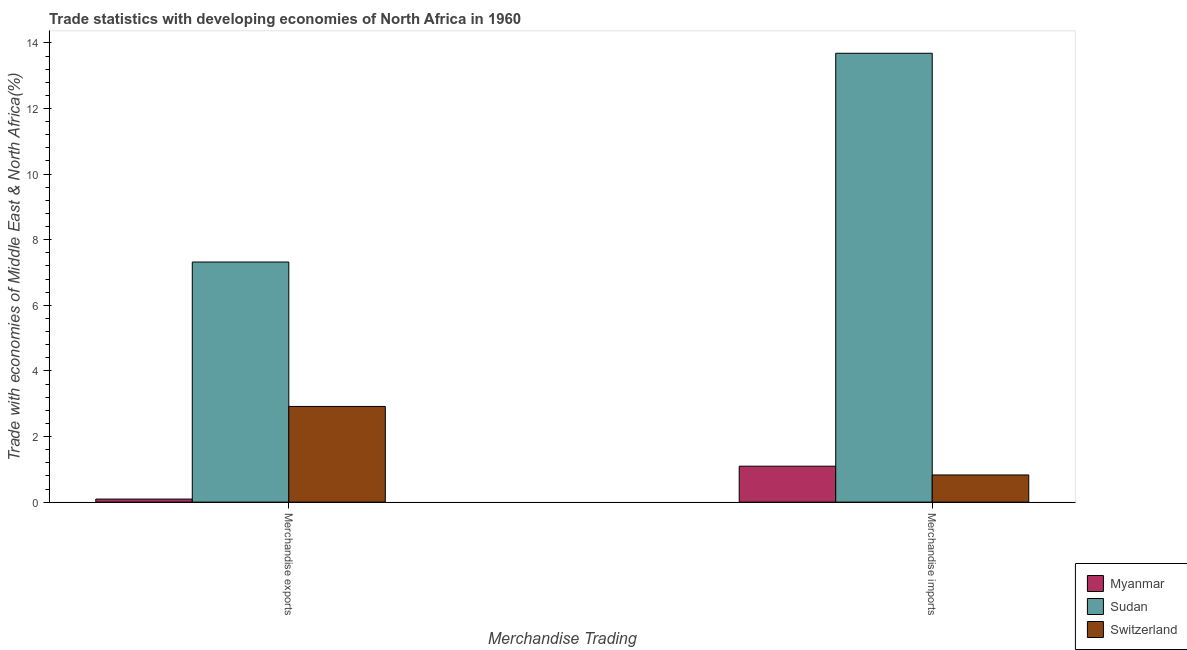Are the number of bars per tick equal to the number of legend labels?
Provide a succinct answer. Yes. Are the number of bars on each tick of the X-axis equal?
Ensure brevity in your answer.  Yes. How many bars are there on the 2nd tick from the left?
Your response must be concise. 3. How many bars are there on the 1st tick from the right?
Your response must be concise. 3. What is the merchandise imports in Myanmar?
Ensure brevity in your answer.  1.1. Across all countries, what is the maximum merchandise imports?
Make the answer very short. 13.68. Across all countries, what is the minimum merchandise exports?
Your response must be concise. 0.09. In which country was the merchandise imports maximum?
Make the answer very short. Sudan. In which country was the merchandise imports minimum?
Your answer should be compact. Switzerland. What is the total merchandise exports in the graph?
Your answer should be very brief. 10.33. What is the difference between the merchandise imports in Myanmar and that in Switzerland?
Your answer should be compact. 0.27. What is the difference between the merchandise exports in Switzerland and the merchandise imports in Myanmar?
Offer a terse response. 1.82. What is the average merchandise exports per country?
Offer a terse response. 3.44. What is the difference between the merchandise exports and merchandise imports in Sudan?
Keep it short and to the point. -6.36. What is the ratio of the merchandise imports in Switzerland to that in Myanmar?
Your response must be concise. 0.76. In how many countries, is the merchandise imports greater than the average merchandise imports taken over all countries?
Keep it short and to the point. 1. What does the 3rd bar from the left in Merchandise imports represents?
Ensure brevity in your answer.  Switzerland. What does the 2nd bar from the right in Merchandise imports represents?
Provide a succinct answer. Sudan. Does the graph contain grids?
Your answer should be very brief. No. What is the title of the graph?
Your answer should be compact. Trade statistics with developing economies of North Africa in 1960. What is the label or title of the X-axis?
Your answer should be very brief. Merchandise Trading. What is the label or title of the Y-axis?
Make the answer very short. Trade with economies of Middle East & North Africa(%). What is the Trade with economies of Middle East & North Africa(%) in Myanmar in Merchandise exports?
Your answer should be compact. 0.09. What is the Trade with economies of Middle East & North Africa(%) in Sudan in Merchandise exports?
Your response must be concise. 7.32. What is the Trade with economies of Middle East & North Africa(%) in Switzerland in Merchandise exports?
Make the answer very short. 2.92. What is the Trade with economies of Middle East & North Africa(%) of Myanmar in Merchandise imports?
Offer a terse response. 1.1. What is the Trade with economies of Middle East & North Africa(%) of Sudan in Merchandise imports?
Ensure brevity in your answer.  13.68. What is the Trade with economies of Middle East & North Africa(%) in Switzerland in Merchandise imports?
Offer a very short reply. 0.83. Across all Merchandise Trading, what is the maximum Trade with economies of Middle East & North Africa(%) of Myanmar?
Provide a short and direct response. 1.1. Across all Merchandise Trading, what is the maximum Trade with economies of Middle East & North Africa(%) in Sudan?
Keep it short and to the point. 13.68. Across all Merchandise Trading, what is the maximum Trade with economies of Middle East & North Africa(%) in Switzerland?
Provide a succinct answer. 2.92. Across all Merchandise Trading, what is the minimum Trade with economies of Middle East & North Africa(%) of Myanmar?
Your response must be concise. 0.09. Across all Merchandise Trading, what is the minimum Trade with economies of Middle East & North Africa(%) in Sudan?
Offer a very short reply. 7.32. Across all Merchandise Trading, what is the minimum Trade with economies of Middle East & North Africa(%) of Switzerland?
Give a very brief answer. 0.83. What is the total Trade with economies of Middle East & North Africa(%) of Myanmar in the graph?
Provide a short and direct response. 1.19. What is the total Trade with economies of Middle East & North Africa(%) of Sudan in the graph?
Provide a short and direct response. 21. What is the total Trade with economies of Middle East & North Africa(%) of Switzerland in the graph?
Your answer should be compact. 3.75. What is the difference between the Trade with economies of Middle East & North Africa(%) in Myanmar in Merchandise exports and that in Merchandise imports?
Give a very brief answer. -1. What is the difference between the Trade with economies of Middle East & North Africa(%) of Sudan in Merchandise exports and that in Merchandise imports?
Keep it short and to the point. -6.36. What is the difference between the Trade with economies of Middle East & North Africa(%) of Switzerland in Merchandise exports and that in Merchandise imports?
Your response must be concise. 2.09. What is the difference between the Trade with economies of Middle East & North Africa(%) of Myanmar in Merchandise exports and the Trade with economies of Middle East & North Africa(%) of Sudan in Merchandise imports?
Your answer should be compact. -13.59. What is the difference between the Trade with economies of Middle East & North Africa(%) in Myanmar in Merchandise exports and the Trade with economies of Middle East & North Africa(%) in Switzerland in Merchandise imports?
Give a very brief answer. -0.74. What is the difference between the Trade with economies of Middle East & North Africa(%) of Sudan in Merchandise exports and the Trade with economies of Middle East & North Africa(%) of Switzerland in Merchandise imports?
Ensure brevity in your answer.  6.49. What is the average Trade with economies of Middle East & North Africa(%) in Myanmar per Merchandise Trading?
Offer a very short reply. 0.59. What is the average Trade with economies of Middle East & North Africa(%) of Sudan per Merchandise Trading?
Make the answer very short. 10.5. What is the average Trade with economies of Middle East & North Africa(%) of Switzerland per Merchandise Trading?
Your answer should be very brief. 1.87. What is the difference between the Trade with economies of Middle East & North Africa(%) of Myanmar and Trade with economies of Middle East & North Africa(%) of Sudan in Merchandise exports?
Give a very brief answer. -7.23. What is the difference between the Trade with economies of Middle East & North Africa(%) of Myanmar and Trade with economies of Middle East & North Africa(%) of Switzerland in Merchandise exports?
Offer a terse response. -2.82. What is the difference between the Trade with economies of Middle East & North Africa(%) in Sudan and Trade with economies of Middle East & North Africa(%) in Switzerland in Merchandise exports?
Offer a terse response. 4.4. What is the difference between the Trade with economies of Middle East & North Africa(%) of Myanmar and Trade with economies of Middle East & North Africa(%) of Sudan in Merchandise imports?
Your response must be concise. -12.59. What is the difference between the Trade with economies of Middle East & North Africa(%) in Myanmar and Trade with economies of Middle East & North Africa(%) in Switzerland in Merchandise imports?
Offer a very short reply. 0.27. What is the difference between the Trade with economies of Middle East & North Africa(%) of Sudan and Trade with economies of Middle East & North Africa(%) of Switzerland in Merchandise imports?
Your answer should be very brief. 12.86. What is the ratio of the Trade with economies of Middle East & North Africa(%) of Myanmar in Merchandise exports to that in Merchandise imports?
Provide a short and direct response. 0.08. What is the ratio of the Trade with economies of Middle East & North Africa(%) in Sudan in Merchandise exports to that in Merchandise imports?
Offer a very short reply. 0.53. What is the ratio of the Trade with economies of Middle East & North Africa(%) of Switzerland in Merchandise exports to that in Merchandise imports?
Keep it short and to the point. 3.52. What is the difference between the highest and the second highest Trade with economies of Middle East & North Africa(%) of Myanmar?
Offer a terse response. 1. What is the difference between the highest and the second highest Trade with economies of Middle East & North Africa(%) of Sudan?
Your response must be concise. 6.36. What is the difference between the highest and the second highest Trade with economies of Middle East & North Africa(%) in Switzerland?
Provide a short and direct response. 2.09. What is the difference between the highest and the lowest Trade with economies of Middle East & North Africa(%) of Myanmar?
Give a very brief answer. 1. What is the difference between the highest and the lowest Trade with economies of Middle East & North Africa(%) of Sudan?
Your answer should be very brief. 6.36. What is the difference between the highest and the lowest Trade with economies of Middle East & North Africa(%) of Switzerland?
Your answer should be compact. 2.09. 